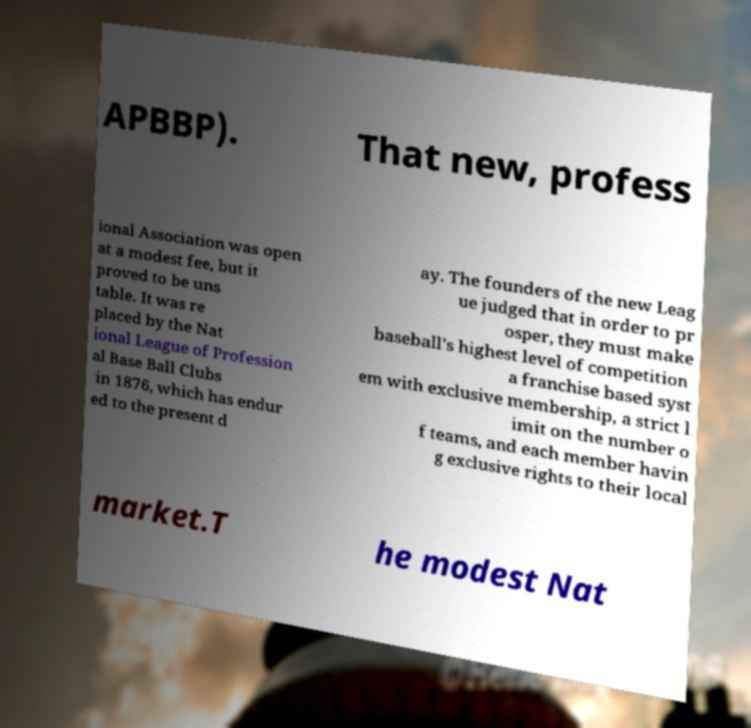There's text embedded in this image that I need extracted. Can you transcribe it verbatim? APBBP). That new, profess ional Association was open at a modest fee, but it proved to be uns table. It was re placed by the Nat ional League of Profession al Base Ball Clubs in 1876, which has endur ed to the present d ay. The founders of the new Leag ue judged that in order to pr osper, they must make baseball's highest level of competition a franchise based syst em with exclusive membership, a strict l imit on the number o f teams, and each member havin g exclusive rights to their local market.T he modest Nat 